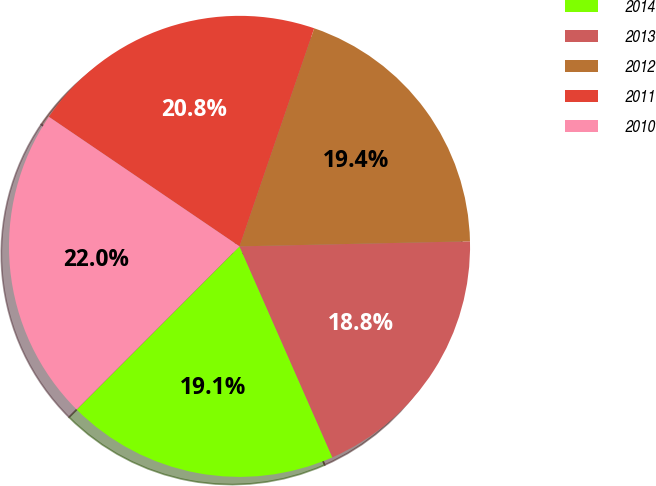Convert chart. <chart><loc_0><loc_0><loc_500><loc_500><pie_chart><fcel>2014<fcel>2013<fcel>2012<fcel>2011<fcel>2010<nl><fcel>19.08%<fcel>18.75%<fcel>19.4%<fcel>20.75%<fcel>22.02%<nl></chart> 